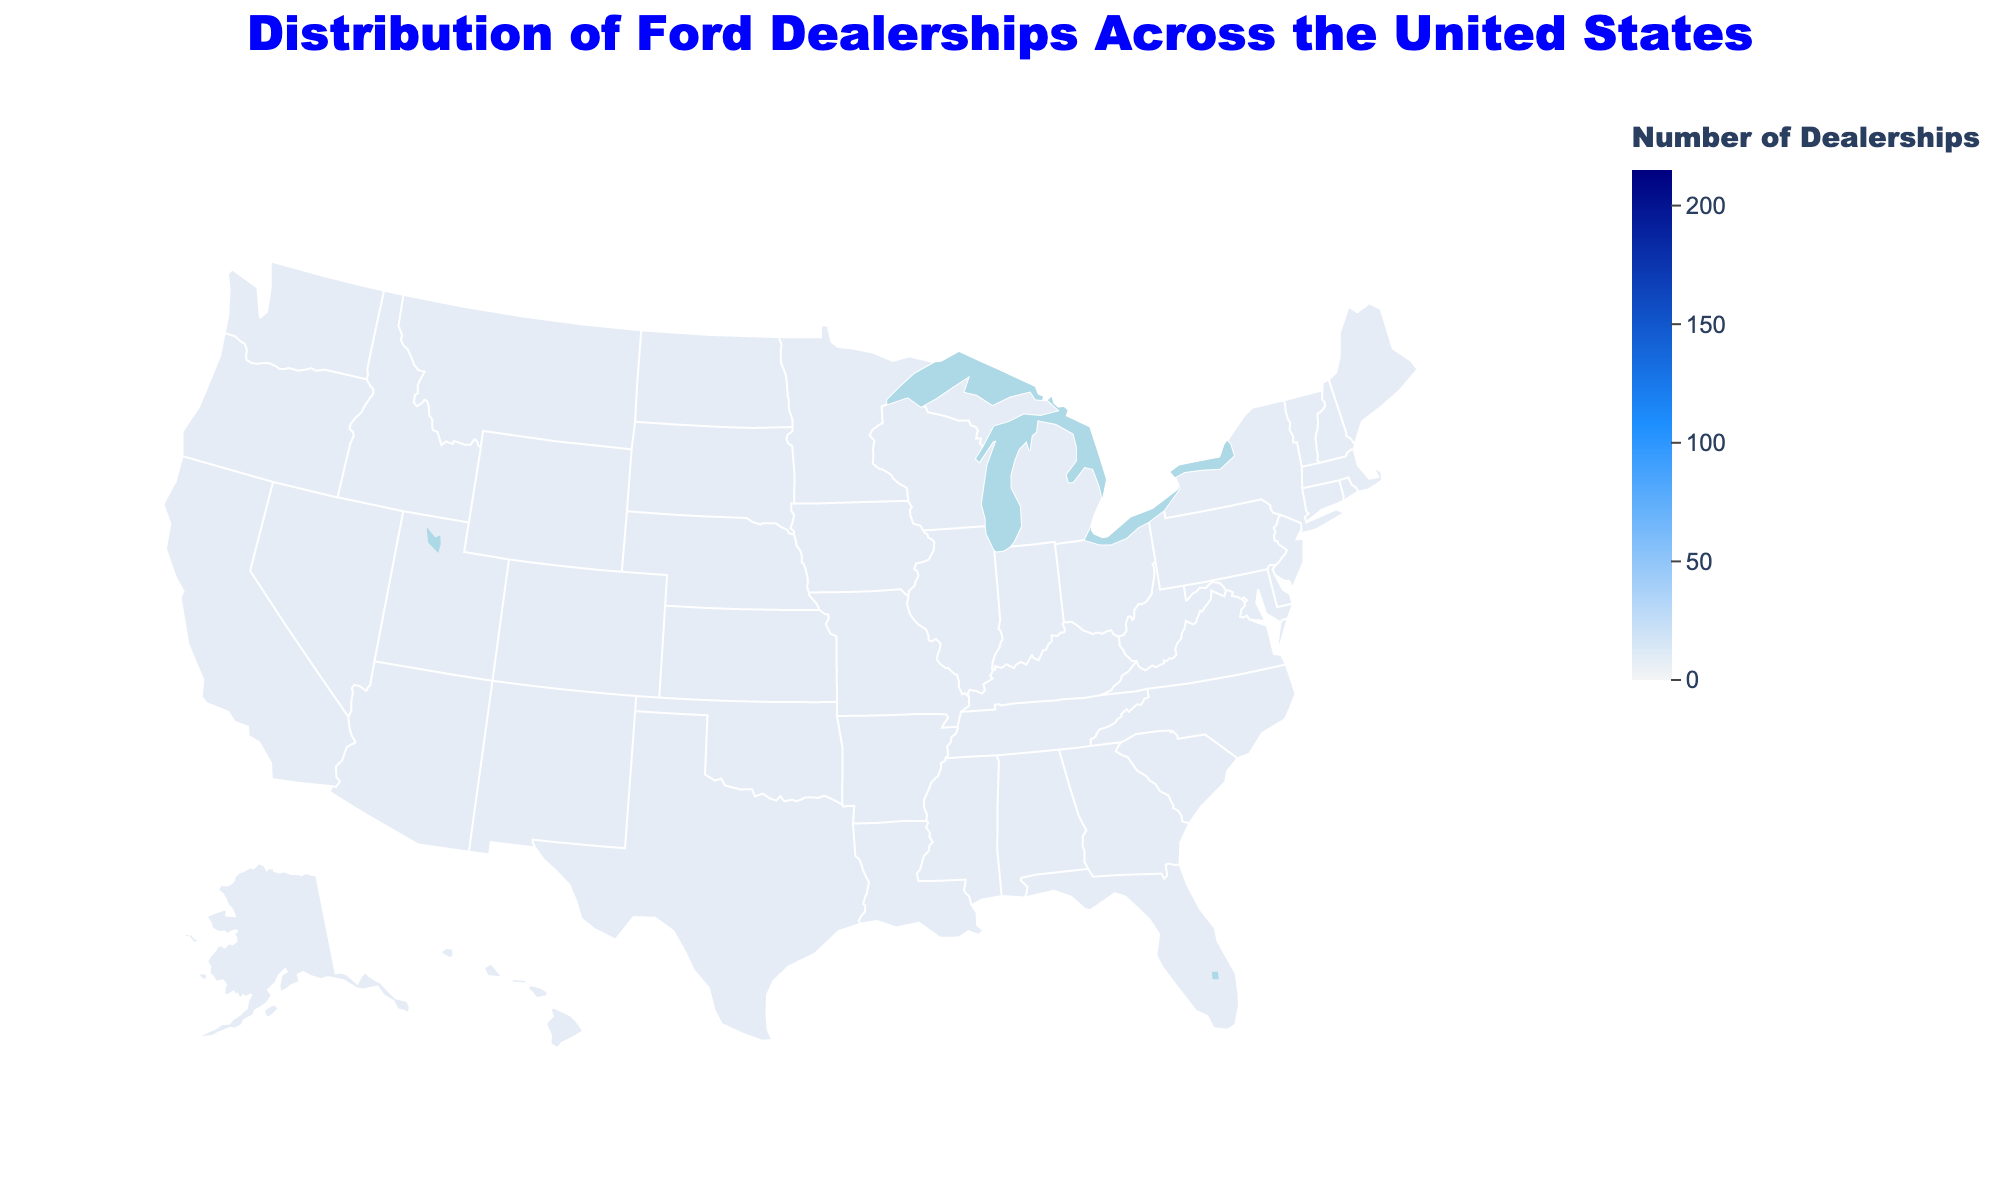What is the title of the figure? The title is usually provided at the top of the figure and describes the plot's main focus. In this case, it tells us about the distribution of Ford dealerships across the U.S.
Answer: Distribution of Ford Dealerships Across the United States Which state has the highest number of Ford dealerships? You can determine this by identifying the state with the darkest color, which represents the highest value. Texas is shaded the darkest, indicating the highest concentration of dealerships.
Answer: Texas How many Ford dealerships are there in California? Look at the annotation or color shading for California to find the exact number of dealerships. California has an annotation indicating 195 dealerships.
Answer: 195 Which states have 150 or more Ford dealerships? Identify the states that fall into the darker shades and check the annotations to confirm they have 150 or more dealerships: Texas, California, Florida, Michigan, and Ohio.
Answer: Texas, California, Florida, Michigan, Ohio What is the difference in the number of Ford dealerships between Texas and New York? Texas has 215 dealerships and New York has 125. Subtract the smaller value from the larger one to find the difference: 215 - 125 = 90.
Answer: 90 Among the states listed, which state has the fewest Ford dealerships? Identify the state with the lightest shading and smallest annotation, which is Kansas with 25 dealerships.
Answer: Kansas How many Ford dealerships are there in the top 3 states combined? Sum the number of dealerships in Texas (215), California (195), and Florida (180): 215 + 195 + 180 = 590.
Answer: 590 Which region of the U.S. (e.g., Northeast, Midwest, South, West) seems to have the most Ford dealerships overall? Visually balance the concentration of darker shades in the different regions. The South (including Texas and Florida) seems to have a high concentration of dealerships.
Answer: South What is the average number of Ford dealerships for the states listed? Sum the total number of dealerships and divide by the number of states: (215 + 195 + 180 + 170 + 150 + 140 + 130 + 125 + 110 + 105 + 95 + 90 + 85 + 80 + 75 + 70 + 65 + 60 + 55 + 50 + 45 + 40 + 35 + 30 + 25) = 2435. There are 25 states, so the average is 2435 / 25 = 97.4.
Answer: 97.4 Which state in the Midwest has the most Ford dealerships? Identify Midwest states and look for the one with the darkest shading or the highest value. Michigan has the highest number of dealerships in the Midwest with 170.
Answer: Michigan 